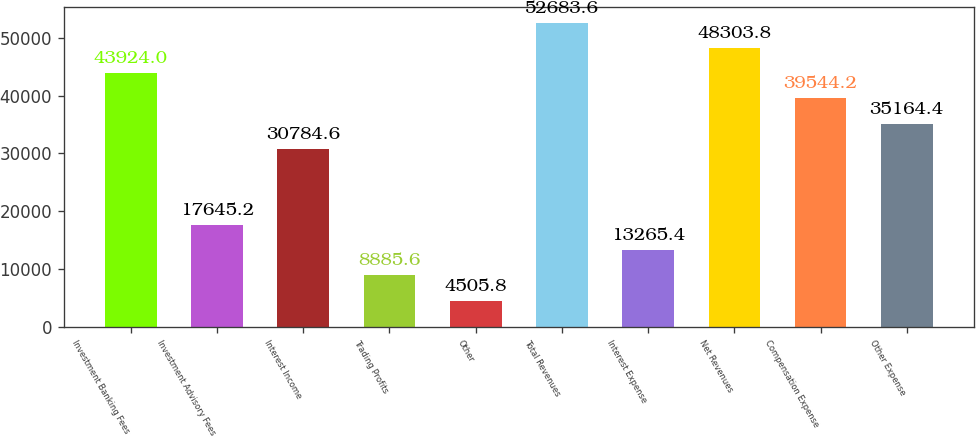<chart> <loc_0><loc_0><loc_500><loc_500><bar_chart><fcel>Investment Banking Fees<fcel>Investment Advisory Fees<fcel>Interest Income<fcel>Trading Profits<fcel>Other<fcel>Total Revenues<fcel>Interest Expense<fcel>Net Revenues<fcel>Compensation Expense<fcel>Other Expense<nl><fcel>43924<fcel>17645.2<fcel>30784.6<fcel>8885.6<fcel>4505.8<fcel>52683.6<fcel>13265.4<fcel>48303.8<fcel>39544.2<fcel>35164.4<nl></chart> 